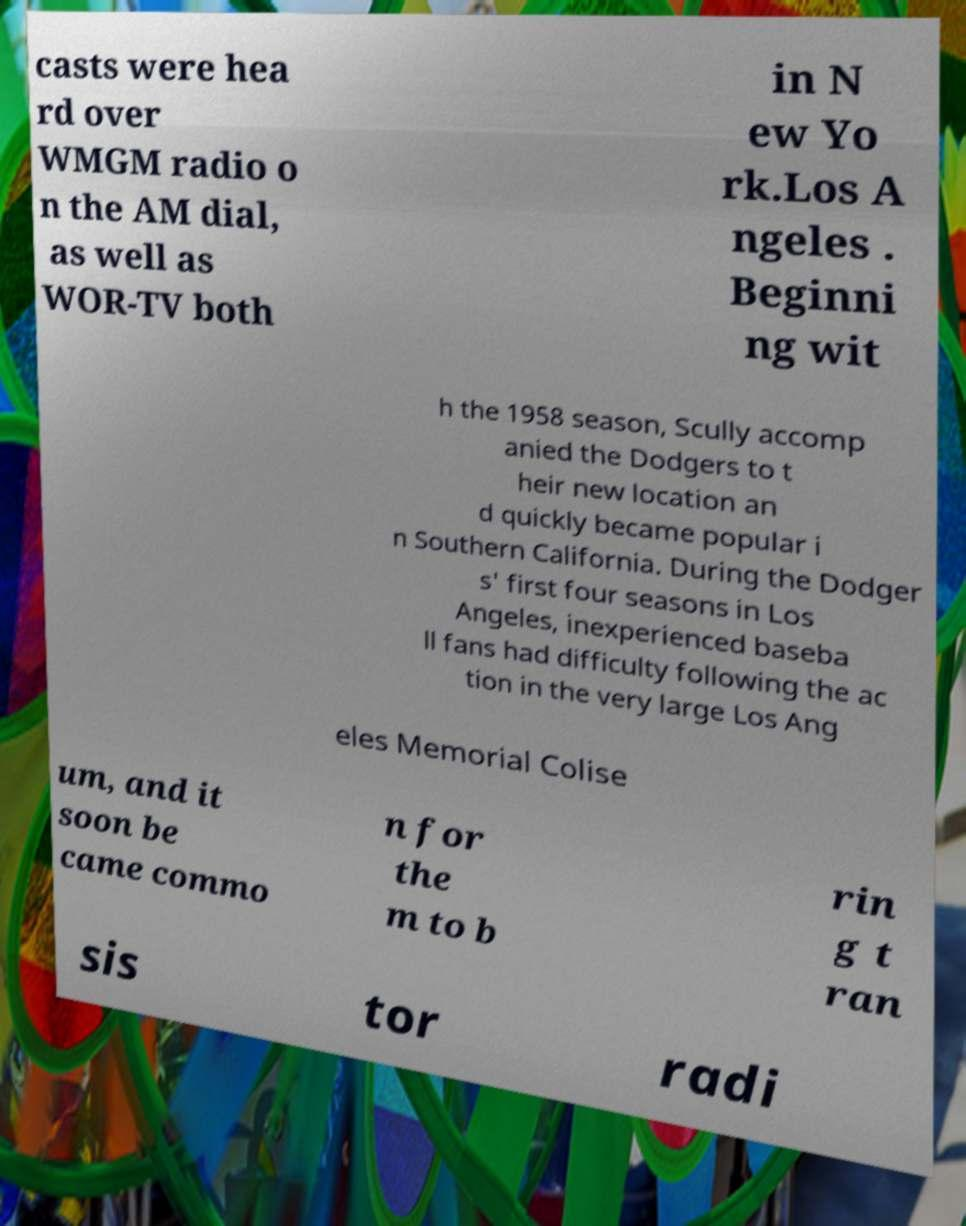Can you read and provide the text displayed in the image?This photo seems to have some interesting text. Can you extract and type it out for me? casts were hea rd over WMGM radio o n the AM dial, as well as WOR-TV both in N ew Yo rk.Los A ngeles . Beginni ng wit h the 1958 season, Scully accomp anied the Dodgers to t heir new location an d quickly became popular i n Southern California. During the Dodger s' first four seasons in Los Angeles, inexperienced baseba ll fans had difficulty following the ac tion in the very large Los Ang eles Memorial Colise um, and it soon be came commo n for the m to b rin g t ran sis tor radi 